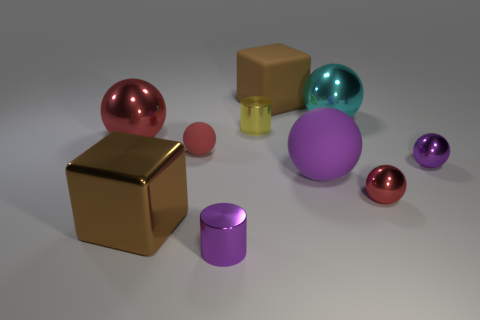There is another big block that is the same color as the big shiny cube; what is its material?
Offer a very short reply. Rubber. Are there any other cubes that have the same color as the large metal cube?
Your response must be concise. Yes. What shape is the tiny rubber thing?
Ensure brevity in your answer.  Sphere. What color is the big matte object behind the large thing to the left of the brown shiny cube?
Offer a terse response. Brown. There is a cylinder that is left of the yellow shiny thing; what is its size?
Make the answer very short. Small. Are there any cyan spheres made of the same material as the yellow cylinder?
Your answer should be compact. Yes. What number of cyan metallic objects are the same shape as the big brown matte object?
Keep it short and to the point. 0. The red metallic thing that is on the right side of the metallic cylinder in front of the red sphere that is behind the red rubber sphere is what shape?
Give a very brief answer. Sphere. There is a small object that is both in front of the large purple rubber object and left of the cyan sphere; what is its material?
Keep it short and to the point. Metal. Do the metal ball on the left side of the matte cube and the big rubber ball have the same size?
Your answer should be compact. Yes. 